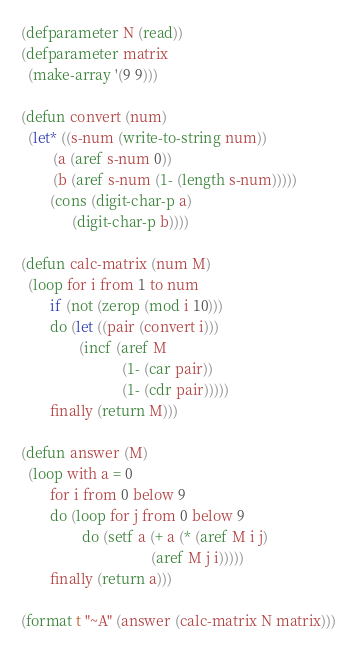Convert code to text. <code><loc_0><loc_0><loc_500><loc_500><_Lisp_>(defparameter N (read))
(defparameter matrix
  (make-array '(9 9)))

(defun convert (num)
  (let* ((s-num (write-to-string num))
         (a (aref s-num 0))
         (b (aref s-num (1- (length s-num)))))
        (cons (digit-char-p a)
              (digit-char-p b))))

(defun calc-matrix (num M)
  (loop for i from 1 to num
        if (not (zerop (mod i 10)))
        do (let ((pair (convert i)))
                (incf (aref M 
                            (1- (car pair))
                            (1- (cdr pair)))))
        finally (return M)))

(defun answer (M)
  (loop with a = 0
   		for i from 0 below 9
        do (loop for j from 0 below 9
                 do (setf a (+ a (* (aref M i j)
                                    (aref M j i)))))
        finally (return a)))

(format t "~A" (answer (calc-matrix N matrix)))
</code> 